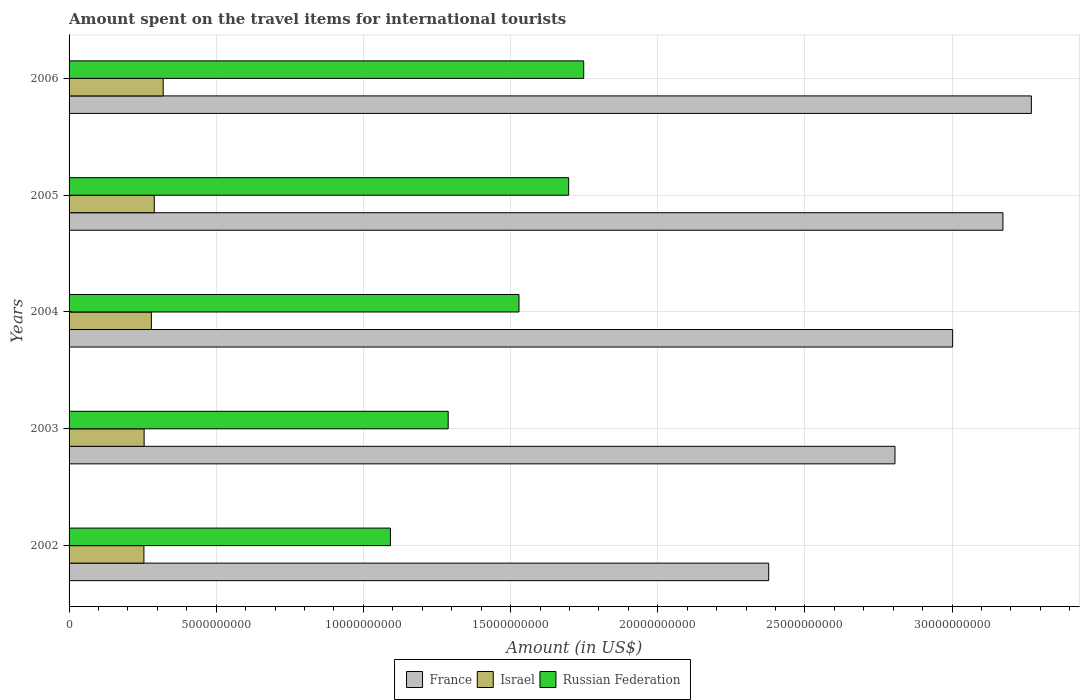How many different coloured bars are there?
Provide a succinct answer. 3. How many groups of bars are there?
Make the answer very short. 5. Are the number of bars per tick equal to the number of legend labels?
Your answer should be compact. Yes. What is the amount spent on the travel items for international tourists in France in 2002?
Your response must be concise. 2.38e+1. Across all years, what is the maximum amount spent on the travel items for international tourists in Russian Federation?
Ensure brevity in your answer.  1.75e+1. Across all years, what is the minimum amount spent on the travel items for international tourists in Russian Federation?
Provide a succinct answer. 1.09e+1. What is the total amount spent on the travel items for international tourists in Russian Federation in the graph?
Your answer should be compact. 7.35e+1. What is the difference between the amount spent on the travel items for international tourists in France in 2003 and that in 2006?
Offer a terse response. -4.63e+09. What is the difference between the amount spent on the travel items for international tourists in Israel in 2006 and the amount spent on the travel items for international tourists in Russian Federation in 2005?
Give a very brief answer. -1.38e+1. What is the average amount spent on the travel items for international tourists in Israel per year?
Provide a short and direct response. 2.80e+09. In the year 2003, what is the difference between the amount spent on the travel items for international tourists in Russian Federation and amount spent on the travel items for international tourists in Israel?
Your response must be concise. 1.03e+1. In how many years, is the amount spent on the travel items for international tourists in Russian Federation greater than 21000000000 US$?
Make the answer very short. 0. What is the ratio of the amount spent on the travel items for international tourists in Russian Federation in 2002 to that in 2006?
Your answer should be compact. 0.62. What is the difference between the highest and the second highest amount spent on the travel items for international tourists in Israel?
Your answer should be very brief. 3.03e+08. What is the difference between the highest and the lowest amount spent on the travel items for international tourists in France?
Give a very brief answer. 8.92e+09. Is the sum of the amount spent on the travel items for international tourists in France in 2003 and 2005 greater than the maximum amount spent on the travel items for international tourists in Israel across all years?
Offer a terse response. Yes. What does the 1st bar from the top in 2004 represents?
Provide a succinct answer. Russian Federation. What does the 1st bar from the bottom in 2003 represents?
Offer a terse response. France. Are all the bars in the graph horizontal?
Offer a terse response. Yes. What is the difference between two consecutive major ticks on the X-axis?
Give a very brief answer. 5.00e+09. Are the values on the major ticks of X-axis written in scientific E-notation?
Offer a very short reply. No. Does the graph contain grids?
Provide a succinct answer. Yes. Where does the legend appear in the graph?
Your answer should be compact. Bottom center. How many legend labels are there?
Offer a terse response. 3. What is the title of the graph?
Offer a terse response. Amount spent on the travel items for international tourists. Does "Gabon" appear as one of the legend labels in the graph?
Your answer should be very brief. No. What is the label or title of the X-axis?
Provide a succinct answer. Amount (in US$). What is the Amount (in US$) in France in 2002?
Ensure brevity in your answer.  2.38e+1. What is the Amount (in US$) in Israel in 2002?
Your answer should be compact. 2.54e+09. What is the Amount (in US$) in Russian Federation in 2002?
Provide a short and direct response. 1.09e+1. What is the Amount (in US$) of France in 2003?
Ensure brevity in your answer.  2.81e+1. What is the Amount (in US$) of Israel in 2003?
Provide a succinct answer. 2.55e+09. What is the Amount (in US$) of Russian Federation in 2003?
Your answer should be compact. 1.29e+1. What is the Amount (in US$) in France in 2004?
Your response must be concise. 3.00e+1. What is the Amount (in US$) of Israel in 2004?
Ensure brevity in your answer.  2.80e+09. What is the Amount (in US$) of Russian Federation in 2004?
Make the answer very short. 1.53e+1. What is the Amount (in US$) in France in 2005?
Offer a very short reply. 3.17e+1. What is the Amount (in US$) of Israel in 2005?
Offer a very short reply. 2.90e+09. What is the Amount (in US$) of Russian Federation in 2005?
Your response must be concise. 1.70e+1. What is the Amount (in US$) of France in 2006?
Provide a succinct answer. 3.27e+1. What is the Amount (in US$) in Israel in 2006?
Give a very brief answer. 3.20e+09. What is the Amount (in US$) of Russian Federation in 2006?
Your answer should be compact. 1.75e+1. Across all years, what is the maximum Amount (in US$) in France?
Provide a short and direct response. 3.27e+1. Across all years, what is the maximum Amount (in US$) in Israel?
Your answer should be very brief. 3.20e+09. Across all years, what is the maximum Amount (in US$) of Russian Federation?
Provide a short and direct response. 1.75e+1. Across all years, what is the minimum Amount (in US$) in France?
Ensure brevity in your answer.  2.38e+1. Across all years, what is the minimum Amount (in US$) of Israel?
Provide a succinct answer. 2.54e+09. Across all years, what is the minimum Amount (in US$) in Russian Federation?
Offer a terse response. 1.09e+1. What is the total Amount (in US$) of France in the graph?
Give a very brief answer. 1.46e+11. What is the total Amount (in US$) in Israel in the graph?
Offer a very short reply. 1.40e+1. What is the total Amount (in US$) in Russian Federation in the graph?
Give a very brief answer. 7.35e+1. What is the difference between the Amount (in US$) in France in 2002 and that in 2003?
Ensure brevity in your answer.  -4.29e+09. What is the difference between the Amount (in US$) of Israel in 2002 and that in 2003?
Keep it short and to the point. -7.00e+06. What is the difference between the Amount (in US$) of Russian Federation in 2002 and that in 2003?
Provide a succinct answer. -1.96e+09. What is the difference between the Amount (in US$) in France in 2002 and that in 2004?
Give a very brief answer. -6.25e+09. What is the difference between the Amount (in US$) in Israel in 2002 and that in 2004?
Offer a very short reply. -2.53e+08. What is the difference between the Amount (in US$) in Russian Federation in 2002 and that in 2004?
Your answer should be compact. -4.37e+09. What is the difference between the Amount (in US$) of France in 2002 and that in 2005?
Provide a succinct answer. -7.96e+09. What is the difference between the Amount (in US$) of Israel in 2002 and that in 2005?
Keep it short and to the point. -3.52e+08. What is the difference between the Amount (in US$) in Russian Federation in 2002 and that in 2005?
Offer a very short reply. -6.05e+09. What is the difference between the Amount (in US$) of France in 2002 and that in 2006?
Provide a succinct answer. -8.92e+09. What is the difference between the Amount (in US$) in Israel in 2002 and that in 2006?
Provide a succinct answer. -6.55e+08. What is the difference between the Amount (in US$) in Russian Federation in 2002 and that in 2006?
Give a very brief answer. -6.57e+09. What is the difference between the Amount (in US$) of France in 2003 and that in 2004?
Make the answer very short. -1.96e+09. What is the difference between the Amount (in US$) in Israel in 2003 and that in 2004?
Provide a short and direct response. -2.46e+08. What is the difference between the Amount (in US$) of Russian Federation in 2003 and that in 2004?
Offer a terse response. -2.40e+09. What is the difference between the Amount (in US$) in France in 2003 and that in 2005?
Your answer should be compact. -3.67e+09. What is the difference between the Amount (in US$) in Israel in 2003 and that in 2005?
Offer a very short reply. -3.45e+08. What is the difference between the Amount (in US$) in Russian Federation in 2003 and that in 2005?
Give a very brief answer. -4.09e+09. What is the difference between the Amount (in US$) in France in 2003 and that in 2006?
Your answer should be compact. -4.63e+09. What is the difference between the Amount (in US$) in Israel in 2003 and that in 2006?
Provide a succinct answer. -6.48e+08. What is the difference between the Amount (in US$) in Russian Federation in 2003 and that in 2006?
Ensure brevity in your answer.  -4.60e+09. What is the difference between the Amount (in US$) in France in 2004 and that in 2005?
Make the answer very short. -1.71e+09. What is the difference between the Amount (in US$) in Israel in 2004 and that in 2005?
Your answer should be very brief. -9.90e+07. What is the difference between the Amount (in US$) in Russian Federation in 2004 and that in 2005?
Your answer should be compact. -1.69e+09. What is the difference between the Amount (in US$) in France in 2004 and that in 2006?
Offer a very short reply. -2.68e+09. What is the difference between the Amount (in US$) of Israel in 2004 and that in 2006?
Provide a short and direct response. -4.02e+08. What is the difference between the Amount (in US$) in Russian Federation in 2004 and that in 2006?
Your response must be concise. -2.20e+09. What is the difference between the Amount (in US$) in France in 2005 and that in 2006?
Offer a very short reply. -9.66e+08. What is the difference between the Amount (in US$) in Israel in 2005 and that in 2006?
Give a very brief answer. -3.03e+08. What is the difference between the Amount (in US$) of Russian Federation in 2005 and that in 2006?
Offer a terse response. -5.12e+08. What is the difference between the Amount (in US$) of France in 2002 and the Amount (in US$) of Israel in 2003?
Ensure brevity in your answer.  2.12e+1. What is the difference between the Amount (in US$) in France in 2002 and the Amount (in US$) in Russian Federation in 2003?
Your answer should be compact. 1.09e+1. What is the difference between the Amount (in US$) of Israel in 2002 and the Amount (in US$) of Russian Federation in 2003?
Ensure brevity in your answer.  -1.03e+1. What is the difference between the Amount (in US$) of France in 2002 and the Amount (in US$) of Israel in 2004?
Your response must be concise. 2.10e+1. What is the difference between the Amount (in US$) of France in 2002 and the Amount (in US$) of Russian Federation in 2004?
Your answer should be compact. 8.48e+09. What is the difference between the Amount (in US$) in Israel in 2002 and the Amount (in US$) in Russian Federation in 2004?
Ensure brevity in your answer.  -1.27e+1. What is the difference between the Amount (in US$) in France in 2002 and the Amount (in US$) in Israel in 2005?
Offer a very short reply. 2.09e+1. What is the difference between the Amount (in US$) in France in 2002 and the Amount (in US$) in Russian Federation in 2005?
Provide a succinct answer. 6.80e+09. What is the difference between the Amount (in US$) of Israel in 2002 and the Amount (in US$) of Russian Federation in 2005?
Give a very brief answer. -1.44e+1. What is the difference between the Amount (in US$) in France in 2002 and the Amount (in US$) in Israel in 2006?
Keep it short and to the point. 2.06e+1. What is the difference between the Amount (in US$) of France in 2002 and the Amount (in US$) of Russian Federation in 2006?
Keep it short and to the point. 6.28e+09. What is the difference between the Amount (in US$) of Israel in 2002 and the Amount (in US$) of Russian Federation in 2006?
Make the answer very short. -1.49e+1. What is the difference between the Amount (in US$) of France in 2003 and the Amount (in US$) of Israel in 2004?
Keep it short and to the point. 2.53e+1. What is the difference between the Amount (in US$) of France in 2003 and the Amount (in US$) of Russian Federation in 2004?
Offer a very short reply. 1.28e+1. What is the difference between the Amount (in US$) of Israel in 2003 and the Amount (in US$) of Russian Federation in 2004?
Give a very brief answer. -1.27e+1. What is the difference between the Amount (in US$) in France in 2003 and the Amount (in US$) in Israel in 2005?
Keep it short and to the point. 2.52e+1. What is the difference between the Amount (in US$) in France in 2003 and the Amount (in US$) in Russian Federation in 2005?
Offer a terse response. 1.11e+1. What is the difference between the Amount (in US$) in Israel in 2003 and the Amount (in US$) in Russian Federation in 2005?
Offer a terse response. -1.44e+1. What is the difference between the Amount (in US$) of France in 2003 and the Amount (in US$) of Israel in 2006?
Make the answer very short. 2.49e+1. What is the difference between the Amount (in US$) in France in 2003 and the Amount (in US$) in Russian Federation in 2006?
Your answer should be compact. 1.06e+1. What is the difference between the Amount (in US$) in Israel in 2003 and the Amount (in US$) in Russian Federation in 2006?
Your response must be concise. -1.49e+1. What is the difference between the Amount (in US$) of France in 2004 and the Amount (in US$) of Israel in 2005?
Your answer should be very brief. 2.71e+1. What is the difference between the Amount (in US$) in France in 2004 and the Amount (in US$) in Russian Federation in 2005?
Provide a short and direct response. 1.30e+1. What is the difference between the Amount (in US$) in Israel in 2004 and the Amount (in US$) in Russian Federation in 2005?
Offer a very short reply. -1.42e+1. What is the difference between the Amount (in US$) in France in 2004 and the Amount (in US$) in Israel in 2006?
Give a very brief answer. 2.68e+1. What is the difference between the Amount (in US$) of France in 2004 and the Amount (in US$) of Russian Federation in 2006?
Make the answer very short. 1.25e+1. What is the difference between the Amount (in US$) in Israel in 2004 and the Amount (in US$) in Russian Federation in 2006?
Ensure brevity in your answer.  -1.47e+1. What is the difference between the Amount (in US$) in France in 2005 and the Amount (in US$) in Israel in 2006?
Make the answer very short. 2.85e+1. What is the difference between the Amount (in US$) in France in 2005 and the Amount (in US$) in Russian Federation in 2006?
Your response must be concise. 1.42e+1. What is the difference between the Amount (in US$) in Israel in 2005 and the Amount (in US$) in Russian Federation in 2006?
Offer a very short reply. -1.46e+1. What is the average Amount (in US$) in France per year?
Keep it short and to the point. 2.93e+1. What is the average Amount (in US$) of Israel per year?
Provide a short and direct response. 2.80e+09. What is the average Amount (in US$) in Russian Federation per year?
Your answer should be compact. 1.47e+1. In the year 2002, what is the difference between the Amount (in US$) of France and Amount (in US$) of Israel?
Your answer should be compact. 2.12e+1. In the year 2002, what is the difference between the Amount (in US$) in France and Amount (in US$) in Russian Federation?
Offer a terse response. 1.29e+1. In the year 2002, what is the difference between the Amount (in US$) in Israel and Amount (in US$) in Russian Federation?
Ensure brevity in your answer.  -8.38e+09. In the year 2003, what is the difference between the Amount (in US$) in France and Amount (in US$) in Israel?
Offer a terse response. 2.55e+1. In the year 2003, what is the difference between the Amount (in US$) of France and Amount (in US$) of Russian Federation?
Your response must be concise. 1.52e+1. In the year 2003, what is the difference between the Amount (in US$) in Israel and Amount (in US$) in Russian Federation?
Offer a very short reply. -1.03e+1. In the year 2004, what is the difference between the Amount (in US$) of France and Amount (in US$) of Israel?
Ensure brevity in your answer.  2.72e+1. In the year 2004, what is the difference between the Amount (in US$) in France and Amount (in US$) in Russian Federation?
Provide a short and direct response. 1.47e+1. In the year 2004, what is the difference between the Amount (in US$) of Israel and Amount (in US$) of Russian Federation?
Keep it short and to the point. -1.25e+1. In the year 2005, what is the difference between the Amount (in US$) of France and Amount (in US$) of Israel?
Your answer should be compact. 2.88e+1. In the year 2005, what is the difference between the Amount (in US$) in France and Amount (in US$) in Russian Federation?
Make the answer very short. 1.48e+1. In the year 2005, what is the difference between the Amount (in US$) of Israel and Amount (in US$) of Russian Federation?
Keep it short and to the point. -1.41e+1. In the year 2006, what is the difference between the Amount (in US$) in France and Amount (in US$) in Israel?
Provide a short and direct response. 2.95e+1. In the year 2006, what is the difference between the Amount (in US$) of France and Amount (in US$) of Russian Federation?
Give a very brief answer. 1.52e+1. In the year 2006, what is the difference between the Amount (in US$) in Israel and Amount (in US$) in Russian Federation?
Ensure brevity in your answer.  -1.43e+1. What is the ratio of the Amount (in US$) in France in 2002 to that in 2003?
Provide a succinct answer. 0.85. What is the ratio of the Amount (in US$) in Israel in 2002 to that in 2003?
Ensure brevity in your answer.  1. What is the ratio of the Amount (in US$) in Russian Federation in 2002 to that in 2003?
Keep it short and to the point. 0.85. What is the ratio of the Amount (in US$) in France in 2002 to that in 2004?
Your answer should be compact. 0.79. What is the ratio of the Amount (in US$) of Israel in 2002 to that in 2004?
Your response must be concise. 0.91. What is the ratio of the Amount (in US$) of Russian Federation in 2002 to that in 2004?
Keep it short and to the point. 0.71. What is the ratio of the Amount (in US$) of France in 2002 to that in 2005?
Make the answer very short. 0.75. What is the ratio of the Amount (in US$) in Israel in 2002 to that in 2005?
Make the answer very short. 0.88. What is the ratio of the Amount (in US$) of Russian Federation in 2002 to that in 2005?
Provide a short and direct response. 0.64. What is the ratio of the Amount (in US$) in France in 2002 to that in 2006?
Give a very brief answer. 0.73. What is the ratio of the Amount (in US$) in Israel in 2002 to that in 2006?
Keep it short and to the point. 0.8. What is the ratio of the Amount (in US$) of Russian Federation in 2002 to that in 2006?
Your response must be concise. 0.62. What is the ratio of the Amount (in US$) of France in 2003 to that in 2004?
Provide a succinct answer. 0.93. What is the ratio of the Amount (in US$) of Israel in 2003 to that in 2004?
Keep it short and to the point. 0.91. What is the ratio of the Amount (in US$) of Russian Federation in 2003 to that in 2004?
Give a very brief answer. 0.84. What is the ratio of the Amount (in US$) in France in 2003 to that in 2005?
Ensure brevity in your answer.  0.88. What is the ratio of the Amount (in US$) in Israel in 2003 to that in 2005?
Offer a terse response. 0.88. What is the ratio of the Amount (in US$) in Russian Federation in 2003 to that in 2005?
Your response must be concise. 0.76. What is the ratio of the Amount (in US$) in France in 2003 to that in 2006?
Make the answer very short. 0.86. What is the ratio of the Amount (in US$) of Israel in 2003 to that in 2006?
Your response must be concise. 0.8. What is the ratio of the Amount (in US$) of Russian Federation in 2003 to that in 2006?
Your response must be concise. 0.74. What is the ratio of the Amount (in US$) in France in 2004 to that in 2005?
Your answer should be very brief. 0.95. What is the ratio of the Amount (in US$) of Israel in 2004 to that in 2005?
Provide a succinct answer. 0.97. What is the ratio of the Amount (in US$) in Russian Federation in 2004 to that in 2005?
Make the answer very short. 0.9. What is the ratio of the Amount (in US$) of France in 2004 to that in 2006?
Your answer should be very brief. 0.92. What is the ratio of the Amount (in US$) in Israel in 2004 to that in 2006?
Provide a short and direct response. 0.87. What is the ratio of the Amount (in US$) of Russian Federation in 2004 to that in 2006?
Provide a short and direct response. 0.87. What is the ratio of the Amount (in US$) in France in 2005 to that in 2006?
Make the answer very short. 0.97. What is the ratio of the Amount (in US$) in Israel in 2005 to that in 2006?
Give a very brief answer. 0.91. What is the ratio of the Amount (in US$) in Russian Federation in 2005 to that in 2006?
Your response must be concise. 0.97. What is the difference between the highest and the second highest Amount (in US$) of France?
Offer a very short reply. 9.66e+08. What is the difference between the highest and the second highest Amount (in US$) of Israel?
Offer a very short reply. 3.03e+08. What is the difference between the highest and the second highest Amount (in US$) in Russian Federation?
Your answer should be compact. 5.12e+08. What is the difference between the highest and the lowest Amount (in US$) in France?
Offer a terse response. 8.92e+09. What is the difference between the highest and the lowest Amount (in US$) of Israel?
Offer a terse response. 6.55e+08. What is the difference between the highest and the lowest Amount (in US$) of Russian Federation?
Give a very brief answer. 6.57e+09. 